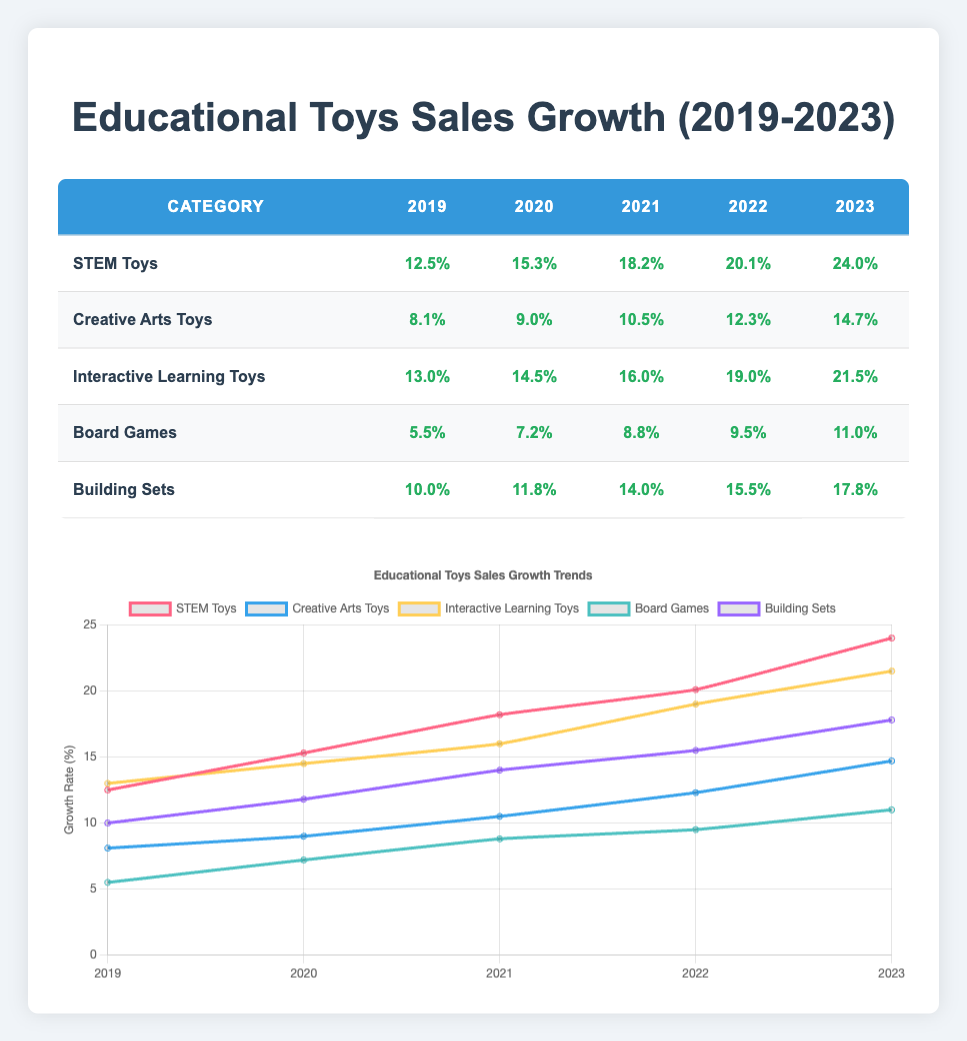What was the sales growth rate of STEM Toys in 2022? The table shows that for the category STEM Toys, the growth rate in 2022 is listed as 20.1%.
Answer: 20.1% Which category had the highest growth rate in 2023? In 2023, the table shows the growth rates for all categories: STEM Toys (24.0%), Creative Arts Toys (14.7%), Interactive Learning Toys (21.5%), Board Games (11.0%), and Building Sets (17.8%). STEM Toys has the highest rate at 24.0%.
Answer: STEM Toys What is the difference in growth rate between Building Sets from 2019 to 2023? From the table, the growth rate for Building Sets in 2019 is 10.0% and in 2023 is 17.8%. The difference is calculated as 17.8% - 10.0% = 7.8%.
Answer: 7.8% Did Interactive Learning Toys have a consistent growth rate every year from 2019 to 2023? Looking at the table, the growth rates for Interactive Learning Toys are 13.0% (2019), 14.5% (2020), 16.0% (2021), 19.0% (2022), and 21.5% (2023)—all are increasing, indicating consistent growth.
Answer: Yes What was the average growth rate of all categories in 2021? To find the average growth rate for 2021, we take the growth rates: STEM Toys (18.2%), Creative Arts Toys (10.5%), Interactive Learning Toys (16.0%), Board Games (8.8%), and Building Sets (14.0%). Summing these values gives 18.2 + 10.5 + 16.0 + 8.8 + 14.0 = 67.5%. Dividing by the number of categories (5) gives an average of 67.5% / 5 = 13.5%.
Answer: 13.5% Which category consistently had the lowest growth rates over the five years? The table reveals that Board Games consistently had the lowest growth rates each year: 5.5% (2019), 7.2% (2020), 8.8% (2021), 9.5% (2022), and 11.0% (2023), making it the category with the lowest overall growth rates.
Answer: Board Games What was the growth rate increase for Creative Arts Toys from 2020 to 2023? By examining the table, the growth rate for Creative Arts Toys in 2020 was 9.0% and in 2023 it was 14.7%. The increase is calculated as 14.7% - 9.0% = 5.7%.
Answer: 5.7% Which two categories had the most similar growth rates in 2022? In 2022, the growth rates are as follows: STEM Toys (20.1%), Creative Arts Toys (12.3%), Interactive Learning Toys (19.0%), Board Games (9.5%), and Building Sets (15.5%). The closest in value are Building Sets (15.5%) and Creative Arts Toys (12.3%), with a difference of 3.2%.
Answer: Building Sets and Creative Arts Toys 